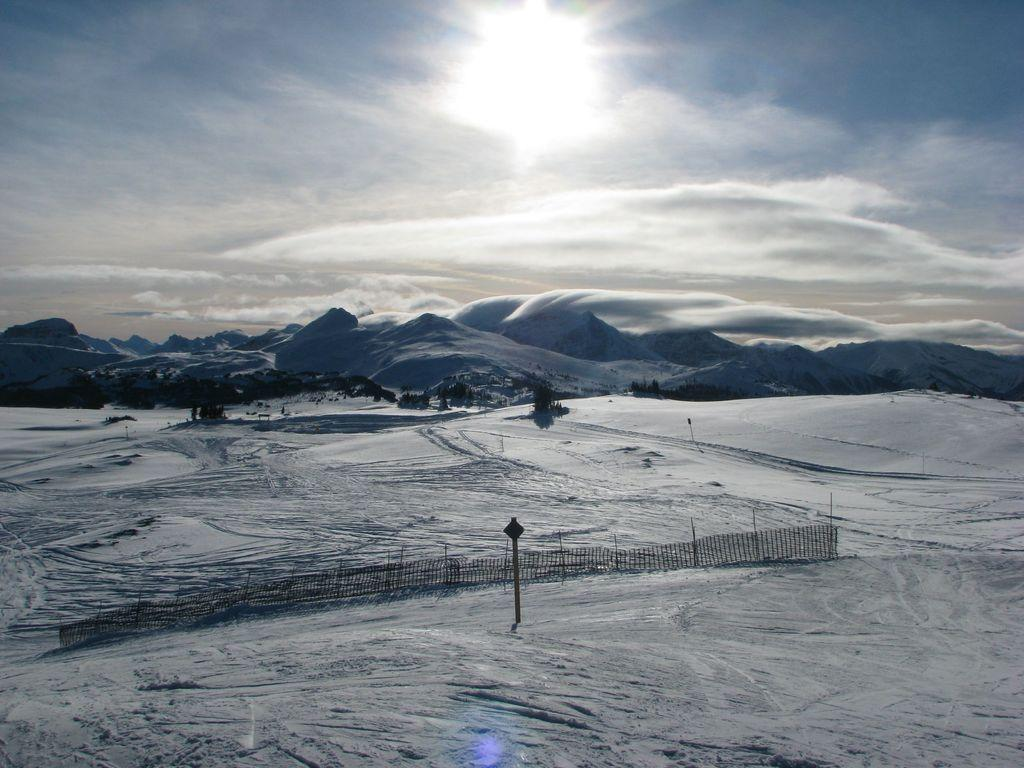What type of weather condition is depicted in the image? There is snow in the image, indicating a cold or wintry weather condition. What structure can be seen in the image? There is a fence in the image. What can be seen in the distance in the image? Hills are visible in the background of the image. What is visible above the hills in the image? The sky is visible in the background of the image. What can be observed in the sky in the image? Clouds are present in the sky. What type of lamp is hanging from the fence in the image? There is no lamp present in the image; it features snow, a fence, hills, and clouds in the sky. What color is the chalk in the image? There is no chalk present in the image. 